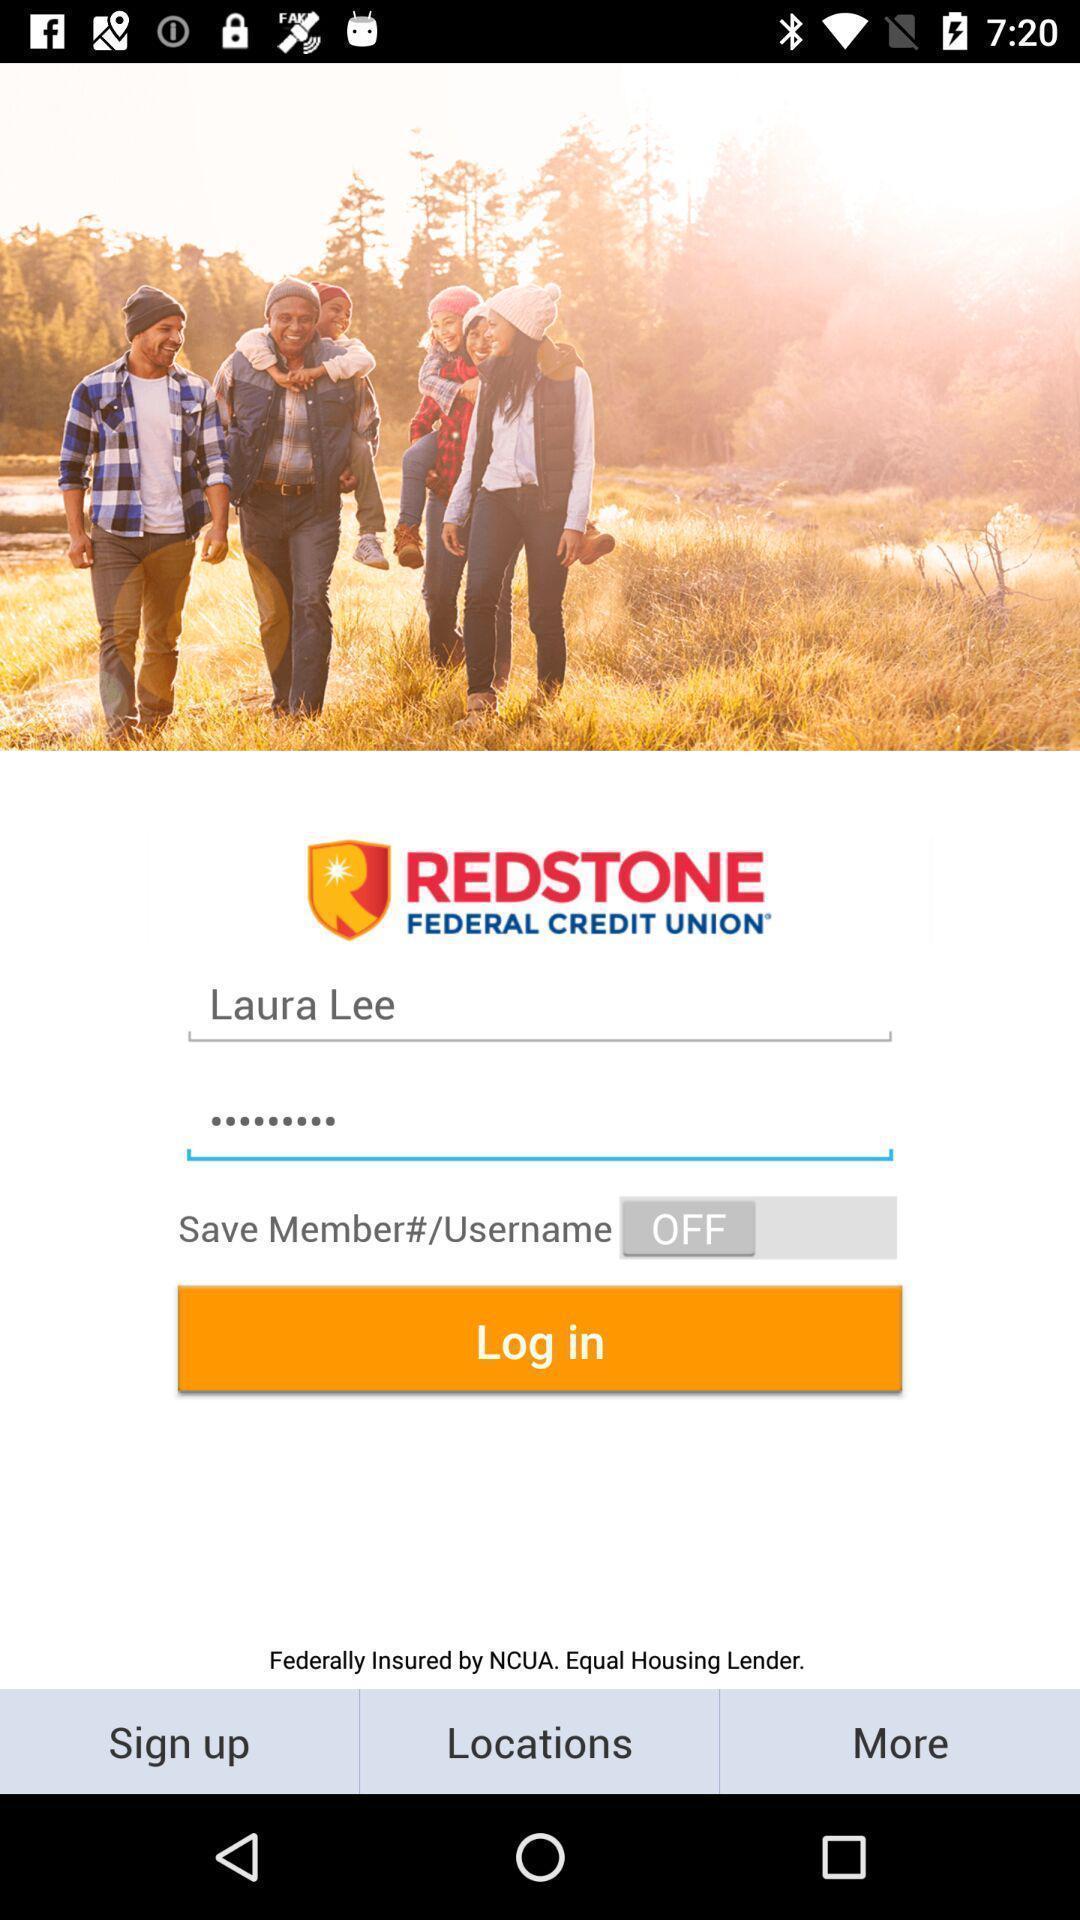Explain what's happening in this screen capture. Welcome page for display app. 